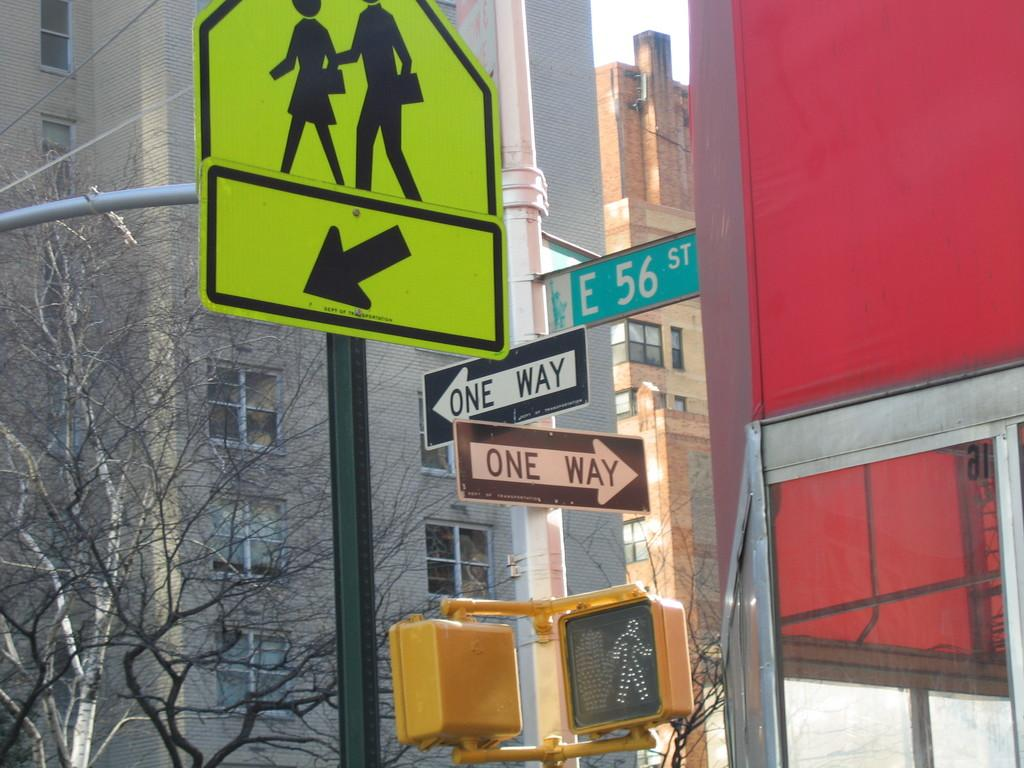<image>
Describe the image concisely. Several Street signs with some reading "One Way". 